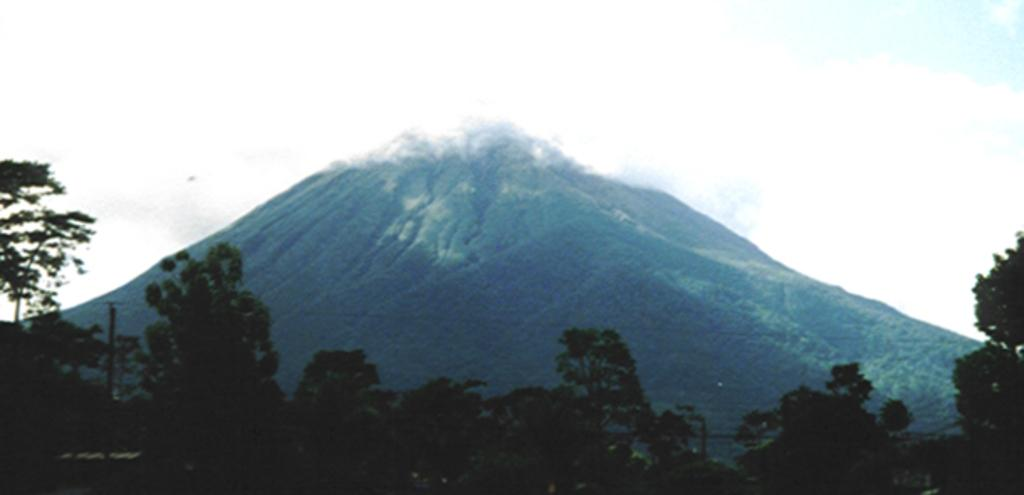What type of vegetation can be seen in the image? There are trees in the image. What geographical feature is visible in the background of the image? There is a mountain in the background of the image. What type of root can be seen growing from the trees in the image? There is no root visible in the image; only the trees themselves are shown. 